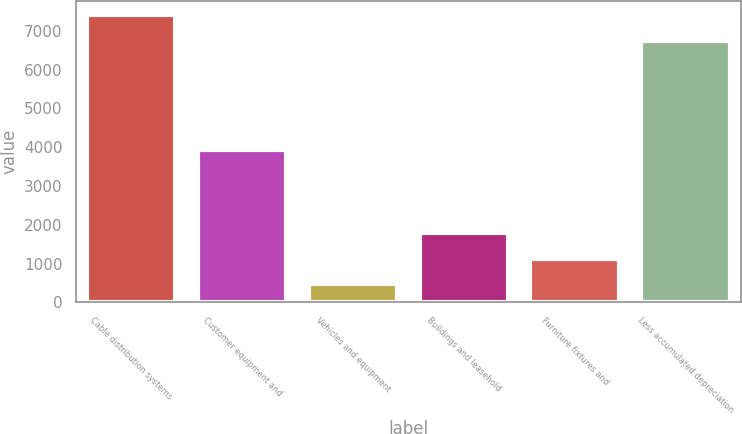Convert chart to OTSL. <chart><loc_0><loc_0><loc_500><loc_500><bar_chart><fcel>Cable distribution systems<fcel>Customer equipment and<fcel>Vehicles and equipment<fcel>Buildings and leasehold<fcel>Furniture fixtures and<fcel>Less accumulated depreciation<nl><fcel>7405.2<fcel>3934<fcel>473<fcel>1785.4<fcel>1129.2<fcel>6749<nl></chart> 